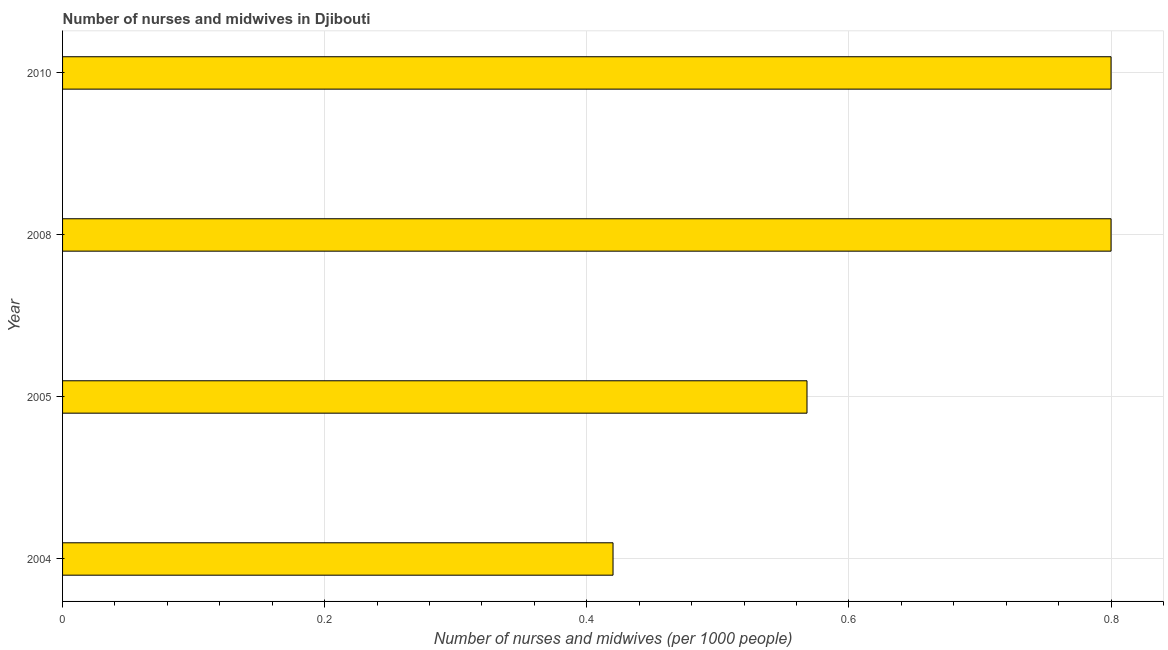Does the graph contain any zero values?
Provide a succinct answer. No. Does the graph contain grids?
Provide a succinct answer. Yes. What is the title of the graph?
Provide a short and direct response. Number of nurses and midwives in Djibouti. What is the label or title of the X-axis?
Ensure brevity in your answer.  Number of nurses and midwives (per 1000 people). What is the number of nurses and midwives in 2010?
Your answer should be very brief. 0.8. Across all years, what is the minimum number of nurses and midwives?
Ensure brevity in your answer.  0.42. What is the sum of the number of nurses and midwives?
Your response must be concise. 2.59. What is the difference between the number of nurses and midwives in 2005 and 2010?
Offer a very short reply. -0.23. What is the average number of nurses and midwives per year?
Ensure brevity in your answer.  0.65. What is the median number of nurses and midwives?
Ensure brevity in your answer.  0.68. In how many years, is the number of nurses and midwives greater than 0.24 ?
Your response must be concise. 4. What is the ratio of the number of nurses and midwives in 2004 to that in 2010?
Provide a succinct answer. 0.53. What is the difference between the highest and the second highest number of nurses and midwives?
Keep it short and to the point. 0. What is the difference between the highest and the lowest number of nurses and midwives?
Provide a succinct answer. 0.38. In how many years, is the number of nurses and midwives greater than the average number of nurses and midwives taken over all years?
Your answer should be compact. 2. Are all the bars in the graph horizontal?
Make the answer very short. Yes. How many years are there in the graph?
Your response must be concise. 4. Are the values on the major ticks of X-axis written in scientific E-notation?
Provide a succinct answer. No. What is the Number of nurses and midwives (per 1000 people) in 2004?
Make the answer very short. 0.42. What is the Number of nurses and midwives (per 1000 people) of 2005?
Offer a very short reply. 0.57. What is the difference between the Number of nurses and midwives (per 1000 people) in 2004 and 2005?
Provide a succinct answer. -0.15. What is the difference between the Number of nurses and midwives (per 1000 people) in 2004 and 2008?
Your response must be concise. -0.38. What is the difference between the Number of nurses and midwives (per 1000 people) in 2004 and 2010?
Provide a succinct answer. -0.38. What is the difference between the Number of nurses and midwives (per 1000 people) in 2005 and 2008?
Give a very brief answer. -0.23. What is the difference between the Number of nurses and midwives (per 1000 people) in 2005 and 2010?
Make the answer very short. -0.23. What is the ratio of the Number of nurses and midwives (per 1000 people) in 2004 to that in 2005?
Your answer should be very brief. 0.74. What is the ratio of the Number of nurses and midwives (per 1000 people) in 2004 to that in 2008?
Make the answer very short. 0.53. What is the ratio of the Number of nurses and midwives (per 1000 people) in 2004 to that in 2010?
Give a very brief answer. 0.53. What is the ratio of the Number of nurses and midwives (per 1000 people) in 2005 to that in 2008?
Keep it short and to the point. 0.71. What is the ratio of the Number of nurses and midwives (per 1000 people) in 2005 to that in 2010?
Give a very brief answer. 0.71. 